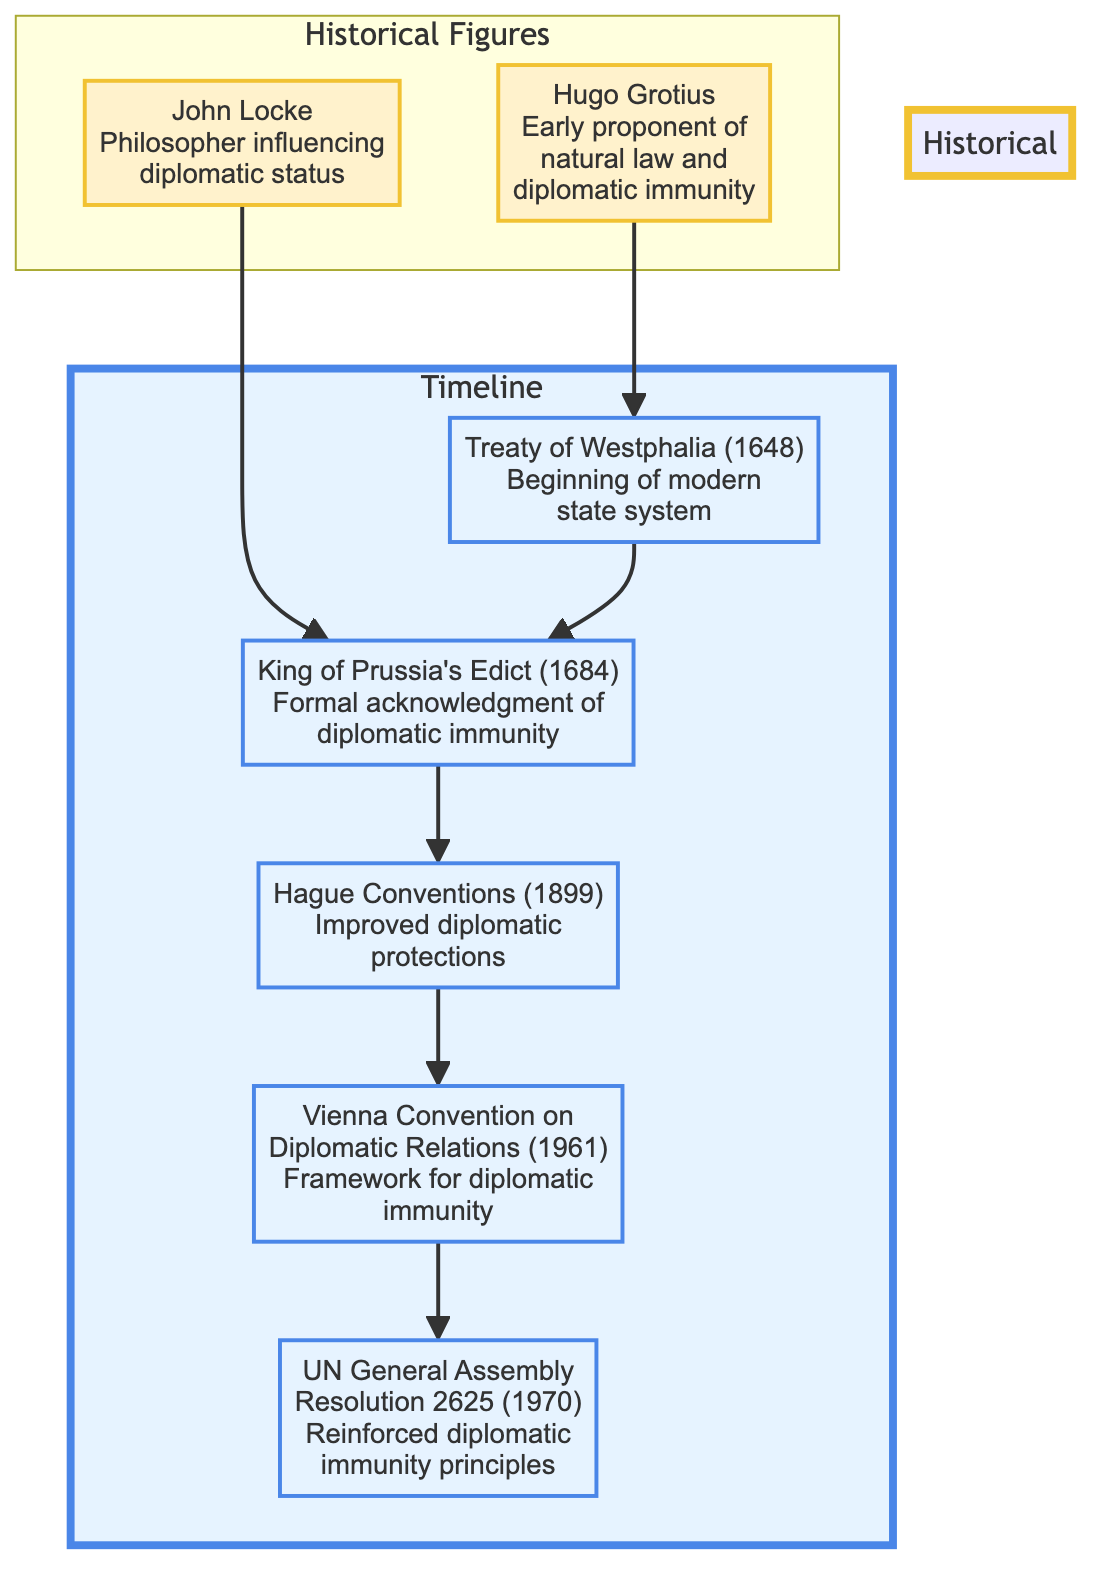What year did the Treaty of Westphalia occur? The diagram states that the Treaty of Westphalia happened in the year 1648, as indicated in the event node labeled "Treaty of Westphalia (1648)."
Answer: 1648 Which historical figure is linked to the King of Prussia's Edict? The diagram shows that John Locke is the historical figure connected to the King of Prussia's Edict through a direct link, as indicated between the respective nodes.
Answer: John Locke What is the last event in the timeline? According to the diagram, the last event listed in the sequence is the UN General Assembly Resolution 2625 dated 1970, which is positioned at the bottom of the flow chart.
Answer: UN General Assembly Resolution 2625 (1970) How many historical figures are represented in the diagram? The diagram includes two historical figures, Hugo Grotius and John Locke, which can be counted from the "Historical Figures" subgraph section.
Answer: 2 What event follows the Hague Conventions in the timeline? Looking at the flow chart, the event that follows the Hague Conventions, which occurred in 1899, is the Vienna Convention on Diplomatic Relations, which is indicated as the next node in the flow.
Answer: Vienna Convention on Diplomatic Relations (1961) Which event is directly influenced by the contributions of Hugo Grotius? The diagram indicates that the Treaty of Westphalia, dated 1648, is the event influenced by Hugo Grotius, as shown by the arrow connecting Grotius to Westphalia in the chart.
Answer: Treaty of Westphalia What is the primary focus of the Vienna Convention on Diplomatic Relations? The flow chart describes that the Vienna Convention established the framework for diplomatic immunity, as clearly stated in the event description of that node.
Answer: Framework for diplomatic immunity What is the relationship between the Treaty of Westphalia and the Hague Conventions? According to the diagram, the Treaty of Westphalia precedes the Hague Conventions in time and is connected directly to it, indicating that Westphalia lays a foundation for the subsequent Hague developments.
Answer: Westphalia precedes Hague Conventions 